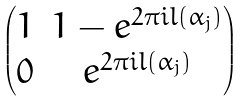<formula> <loc_0><loc_0><loc_500><loc_500>\begin{pmatrix} 1 & 1 - e ^ { 2 \pi i l ( \alpha _ { j } ) } \\ 0 & e ^ { 2 \pi i l ( \alpha _ { j } ) } \end{pmatrix}</formula> 